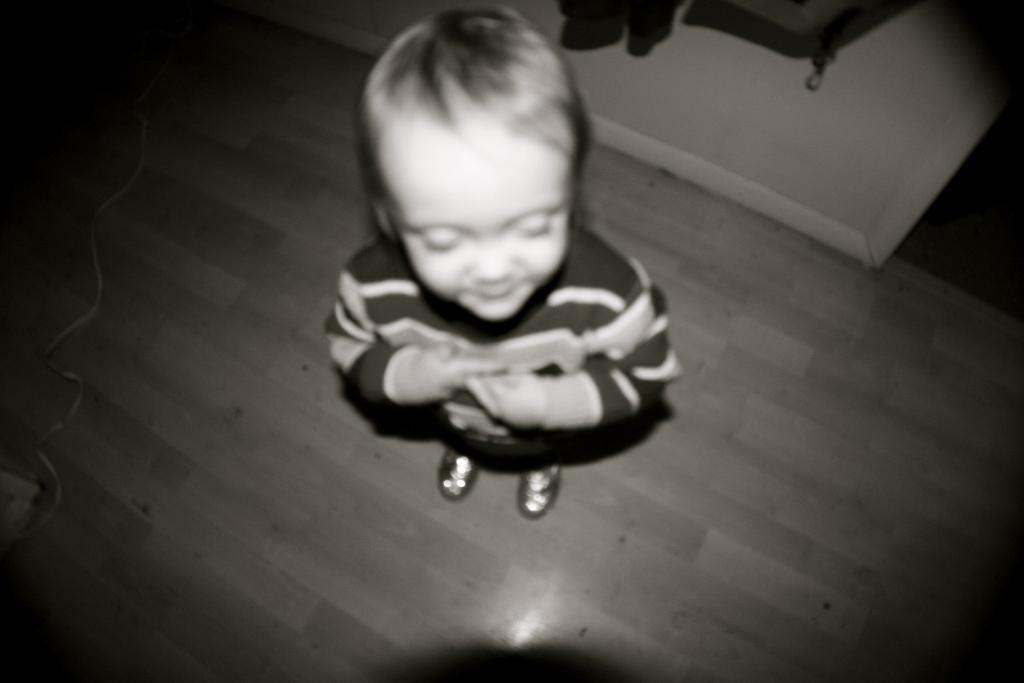Who is the main subject in the image? There is a boy in the image. What is the boy doing in the image? The boy is standing on the floor. What can be seen on the wall in the image? There is a wall with clothes in the image. What is on the floor besides the boy? There is a wire on the floor in the image. What type of sign is the boy holding in the image? There is no sign present in the image; the boy is simply standing on the floor. What is the boy's temper like in the image? The boy's temper cannot be determined from the image, as it only shows the boy standing on the floor. 